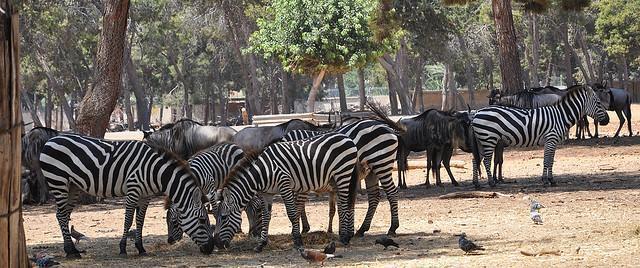How many zebras can you see?
Give a very brief answer. 5. 